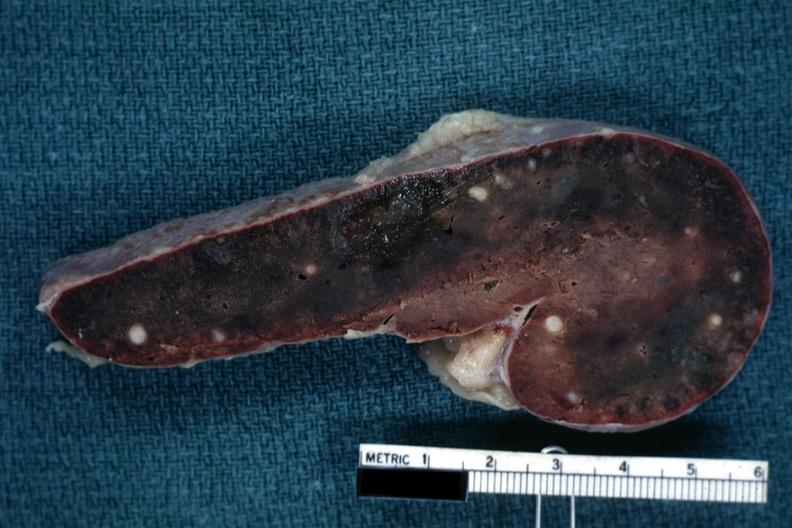what is present?
Answer the question using a single word or phrase. Tuberculosis 